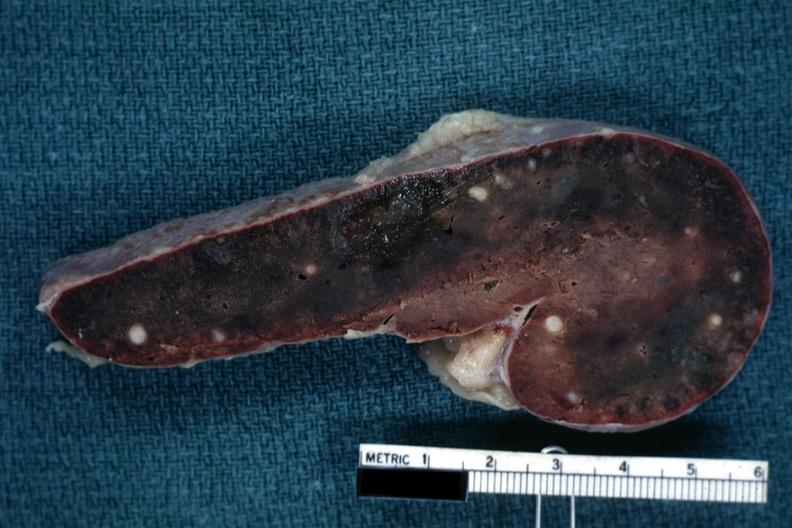what is present?
Answer the question using a single word or phrase. Tuberculosis 